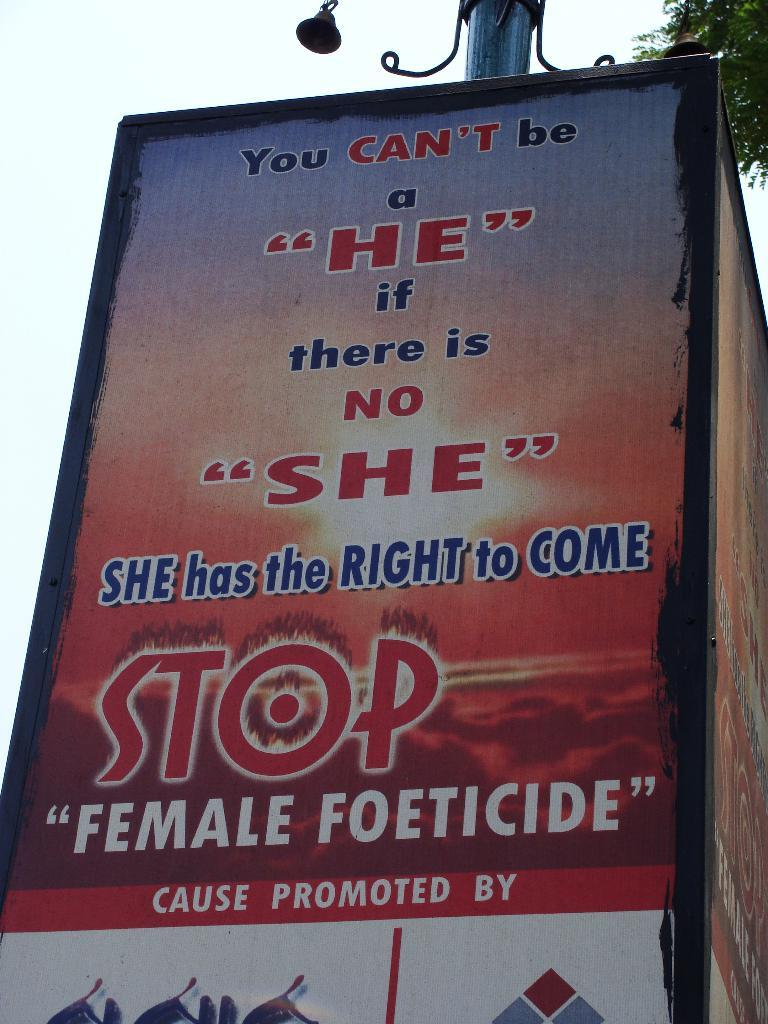<image>
Give a short and clear explanation of the subsequent image. large billboard sign that says "Stop Female Foeticide". 